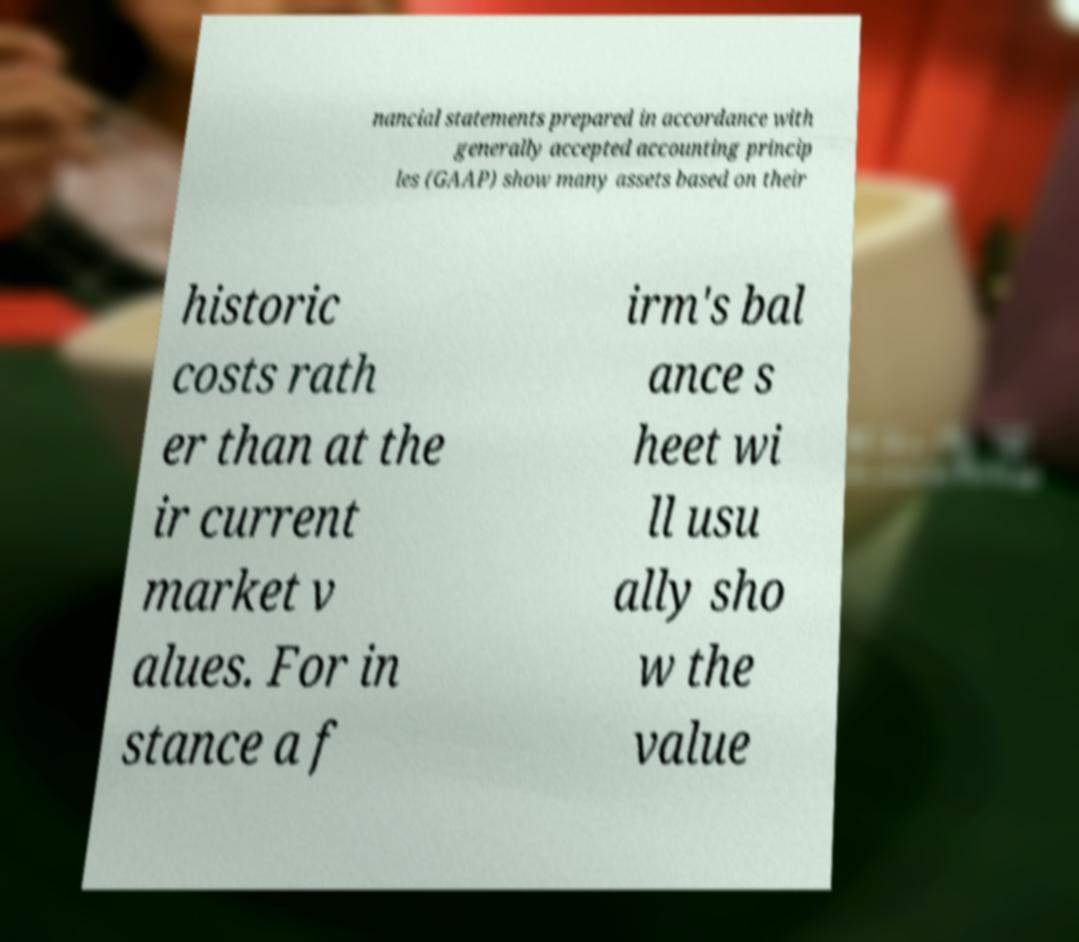Could you assist in decoding the text presented in this image and type it out clearly? nancial statements prepared in accordance with generally accepted accounting princip les (GAAP) show many assets based on their historic costs rath er than at the ir current market v alues. For in stance a f irm's bal ance s heet wi ll usu ally sho w the value 